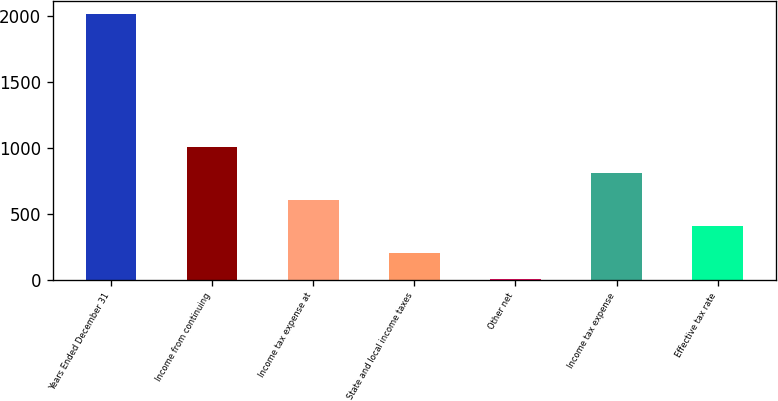Convert chart. <chart><loc_0><loc_0><loc_500><loc_500><bar_chart><fcel>Years Ended December 31<fcel>Income from continuing<fcel>Income tax expense at<fcel>State and local income taxes<fcel>Other net<fcel>Income tax expense<fcel>Effective tax rate<nl><fcel>2012<fcel>1006.5<fcel>604.3<fcel>202.1<fcel>1<fcel>805.4<fcel>403.2<nl></chart> 